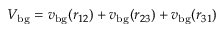Convert formula to latex. <formula><loc_0><loc_0><loc_500><loc_500>V _ { b g } = v _ { b g } ( r _ { 1 2 } ) + v _ { b g } ( r _ { 2 3 } ) + v _ { b g } ( r _ { 3 1 } )</formula> 